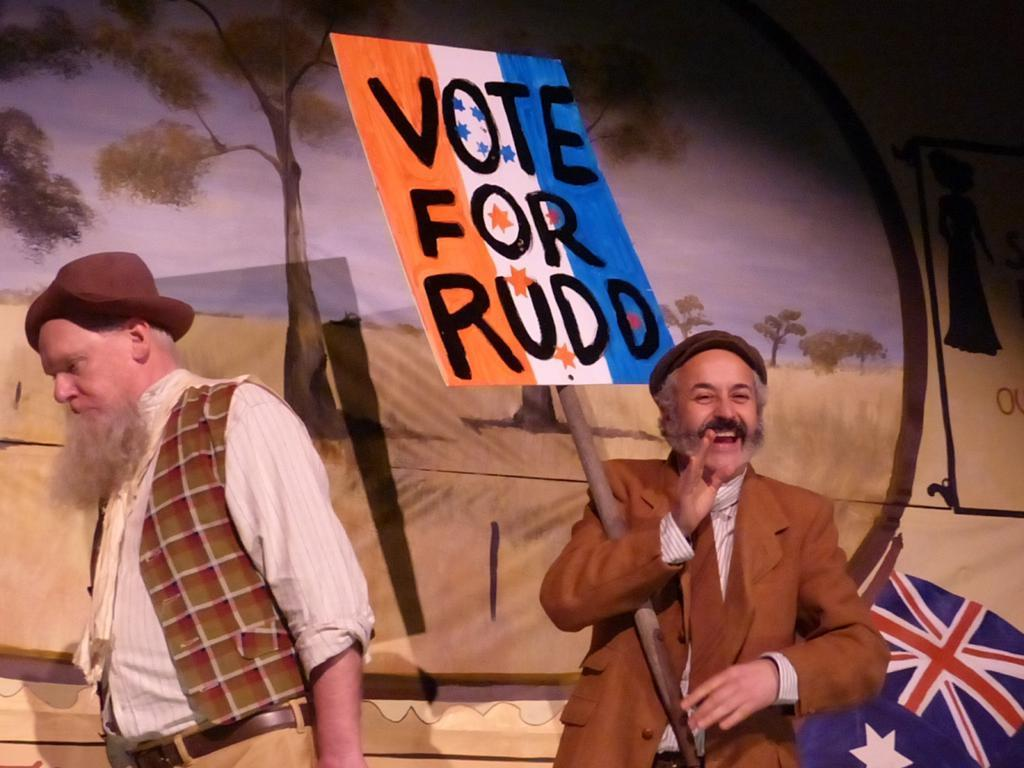How many people are present in the image? There are two people standing in the image. Can you describe the facial expression of one of the people? One of the people is smiling. What is the smiling person holding in the image? The smiling person is holding a board with text on it. What can be seen in the background of the image? There is a painting on the wall in the background. What type of balls are being used for lunch in the image? There are no balls or lunch depicted in the image. Can you tell me the name of the judge in the image? There is no judge present in the image. 